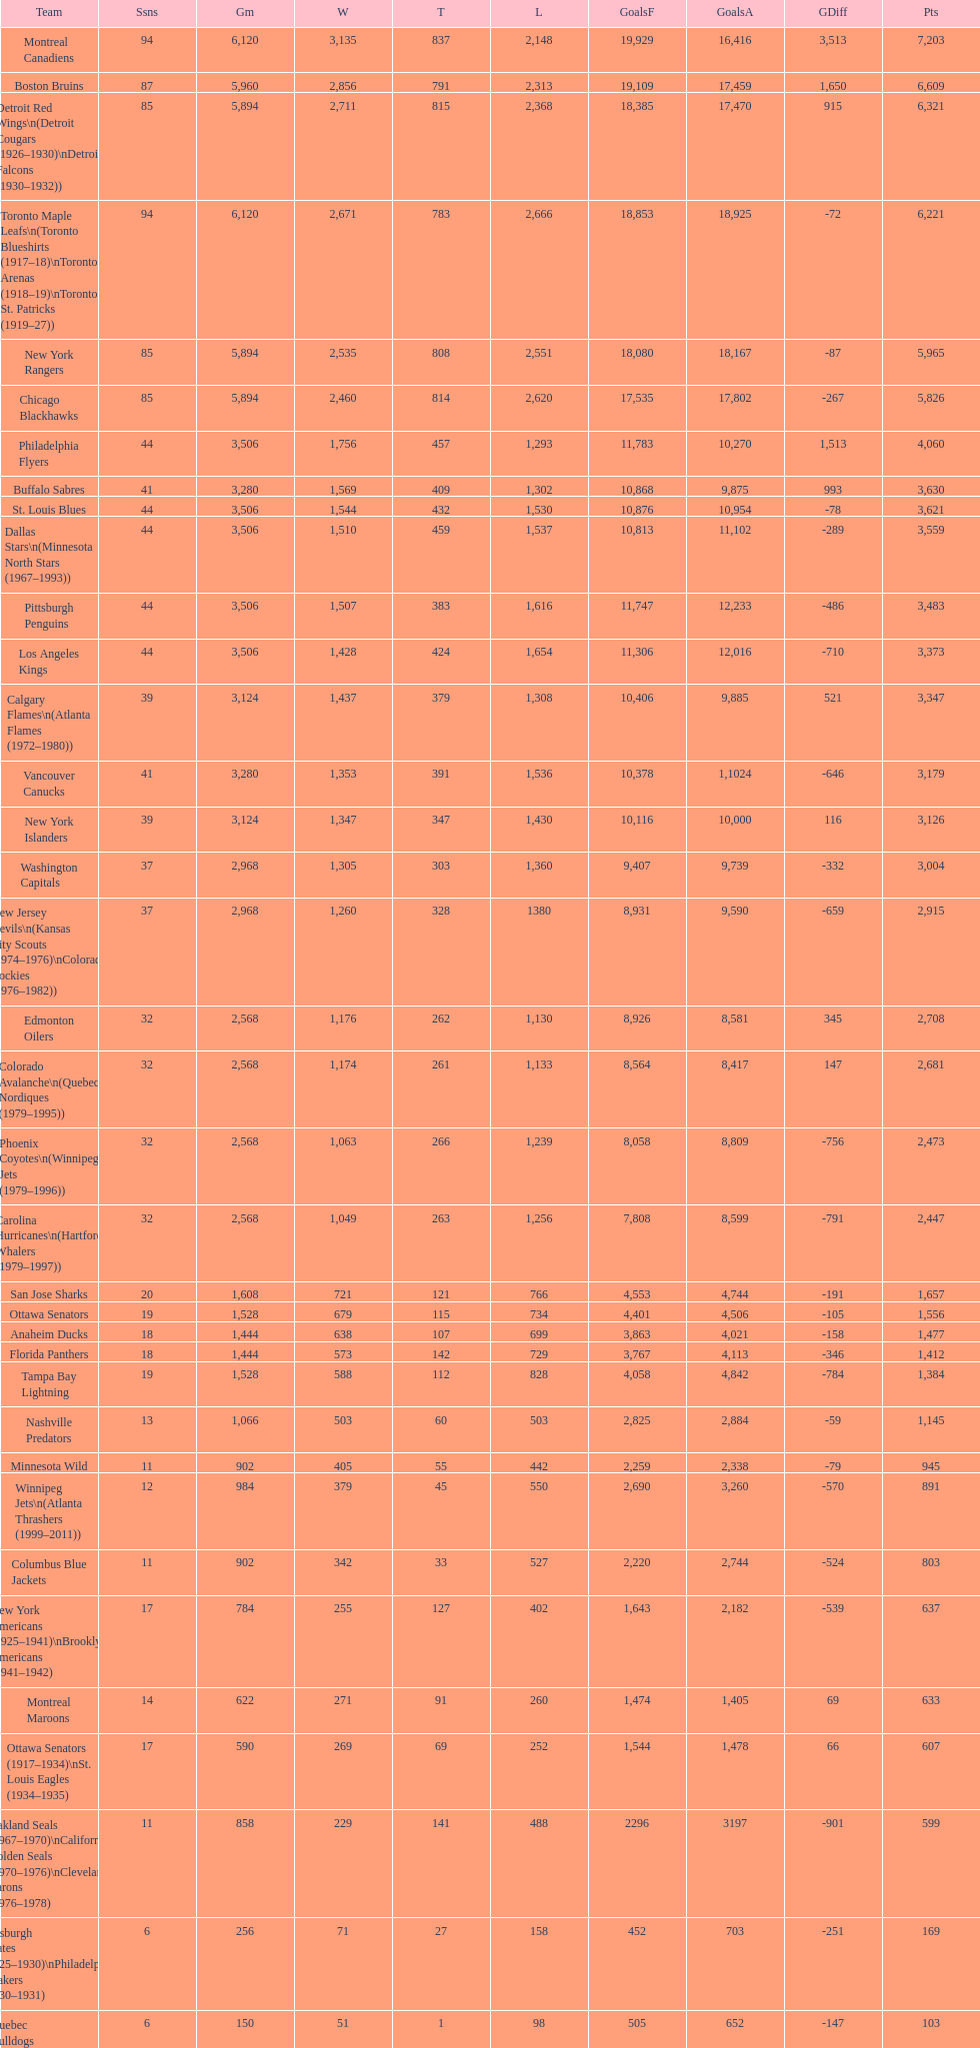Who has the least amount of losses? Montreal Wanderers. Give me the full table as a dictionary. {'header': ['Team', 'Ssns', 'Gm', 'W', 'T', 'L', 'GoalsF', 'GoalsA', 'GDiff', 'Pts'], 'rows': [['Montreal Canadiens', '94', '6,120', '3,135', '837', '2,148', '19,929', '16,416', '3,513', '7,203'], ['Boston Bruins', '87', '5,960', '2,856', '791', '2,313', '19,109', '17,459', '1,650', '6,609'], ['Detroit Red Wings\\n(Detroit Cougars (1926–1930)\\nDetroit Falcons (1930–1932))', '85', '5,894', '2,711', '815', '2,368', '18,385', '17,470', '915', '6,321'], ['Toronto Maple Leafs\\n(Toronto Blueshirts (1917–18)\\nToronto Arenas (1918–19)\\nToronto St. Patricks (1919–27))', '94', '6,120', '2,671', '783', '2,666', '18,853', '18,925', '-72', '6,221'], ['New York Rangers', '85', '5,894', '2,535', '808', '2,551', '18,080', '18,167', '-87', '5,965'], ['Chicago Blackhawks', '85', '5,894', '2,460', '814', '2,620', '17,535', '17,802', '-267', '5,826'], ['Philadelphia Flyers', '44', '3,506', '1,756', '457', '1,293', '11,783', '10,270', '1,513', '4,060'], ['Buffalo Sabres', '41', '3,280', '1,569', '409', '1,302', '10,868', '9,875', '993', '3,630'], ['St. Louis Blues', '44', '3,506', '1,544', '432', '1,530', '10,876', '10,954', '-78', '3,621'], ['Dallas Stars\\n(Minnesota North Stars (1967–1993))', '44', '3,506', '1,510', '459', '1,537', '10,813', '11,102', '-289', '3,559'], ['Pittsburgh Penguins', '44', '3,506', '1,507', '383', '1,616', '11,747', '12,233', '-486', '3,483'], ['Los Angeles Kings', '44', '3,506', '1,428', '424', '1,654', '11,306', '12,016', '-710', '3,373'], ['Calgary Flames\\n(Atlanta Flames (1972–1980))', '39', '3,124', '1,437', '379', '1,308', '10,406', '9,885', '521', '3,347'], ['Vancouver Canucks', '41', '3,280', '1,353', '391', '1,536', '10,378', '1,1024', '-646', '3,179'], ['New York Islanders', '39', '3,124', '1,347', '347', '1,430', '10,116', '10,000', '116', '3,126'], ['Washington Capitals', '37', '2,968', '1,305', '303', '1,360', '9,407', '9,739', '-332', '3,004'], ['New Jersey Devils\\n(Kansas City Scouts (1974–1976)\\nColorado Rockies (1976–1982))', '37', '2,968', '1,260', '328', '1380', '8,931', '9,590', '-659', '2,915'], ['Edmonton Oilers', '32', '2,568', '1,176', '262', '1,130', '8,926', '8,581', '345', '2,708'], ['Colorado Avalanche\\n(Quebec Nordiques (1979–1995))', '32', '2,568', '1,174', '261', '1,133', '8,564', '8,417', '147', '2,681'], ['Phoenix Coyotes\\n(Winnipeg Jets (1979–1996))', '32', '2,568', '1,063', '266', '1,239', '8,058', '8,809', '-756', '2,473'], ['Carolina Hurricanes\\n(Hartford Whalers (1979–1997))', '32', '2,568', '1,049', '263', '1,256', '7,808', '8,599', '-791', '2,447'], ['San Jose Sharks', '20', '1,608', '721', '121', '766', '4,553', '4,744', '-191', '1,657'], ['Ottawa Senators', '19', '1,528', '679', '115', '734', '4,401', '4,506', '-105', '1,556'], ['Anaheim Ducks', '18', '1,444', '638', '107', '699', '3,863', '4,021', '-158', '1,477'], ['Florida Panthers', '18', '1,444', '573', '142', '729', '3,767', '4,113', '-346', '1,412'], ['Tampa Bay Lightning', '19', '1,528', '588', '112', '828', '4,058', '4,842', '-784', '1,384'], ['Nashville Predators', '13', '1,066', '503', '60', '503', '2,825', '2,884', '-59', '1,145'], ['Minnesota Wild', '11', '902', '405', '55', '442', '2,259', '2,338', '-79', '945'], ['Winnipeg Jets\\n(Atlanta Thrashers (1999–2011))', '12', '984', '379', '45', '550', '2,690', '3,260', '-570', '891'], ['Columbus Blue Jackets', '11', '902', '342', '33', '527', '2,220', '2,744', '-524', '803'], ['New York Americans (1925–1941)\\nBrooklyn Americans (1941–1942)', '17', '784', '255', '127', '402', '1,643', '2,182', '-539', '637'], ['Montreal Maroons', '14', '622', '271', '91', '260', '1,474', '1,405', '69', '633'], ['Ottawa Senators (1917–1934)\\nSt. Louis Eagles (1934–1935)', '17', '590', '269', '69', '252', '1,544', '1,478', '66', '607'], ['Oakland Seals (1967–1970)\\nCalifornia Golden Seals (1970–1976)\\nCleveland Barons (1976–1978)', '11', '858', '229', '141', '488', '2296', '3197', '-901', '599'], ['Pittsburgh Pirates (1925–1930)\\nPhiladelphia Quakers (1930–1931)', '6', '256', '71', '27', '158', '452', '703', '-251', '169'], ['Quebec Bulldogs (1919–1920)\\nHamilton Tigers (1920–1925)', '6', '150', '51', '1', '98', '505', '652', '-147', '103'], ['Montreal Wanderers', '1', '6', '1', '0', '5', '17', '35', '-18', '2']]} 